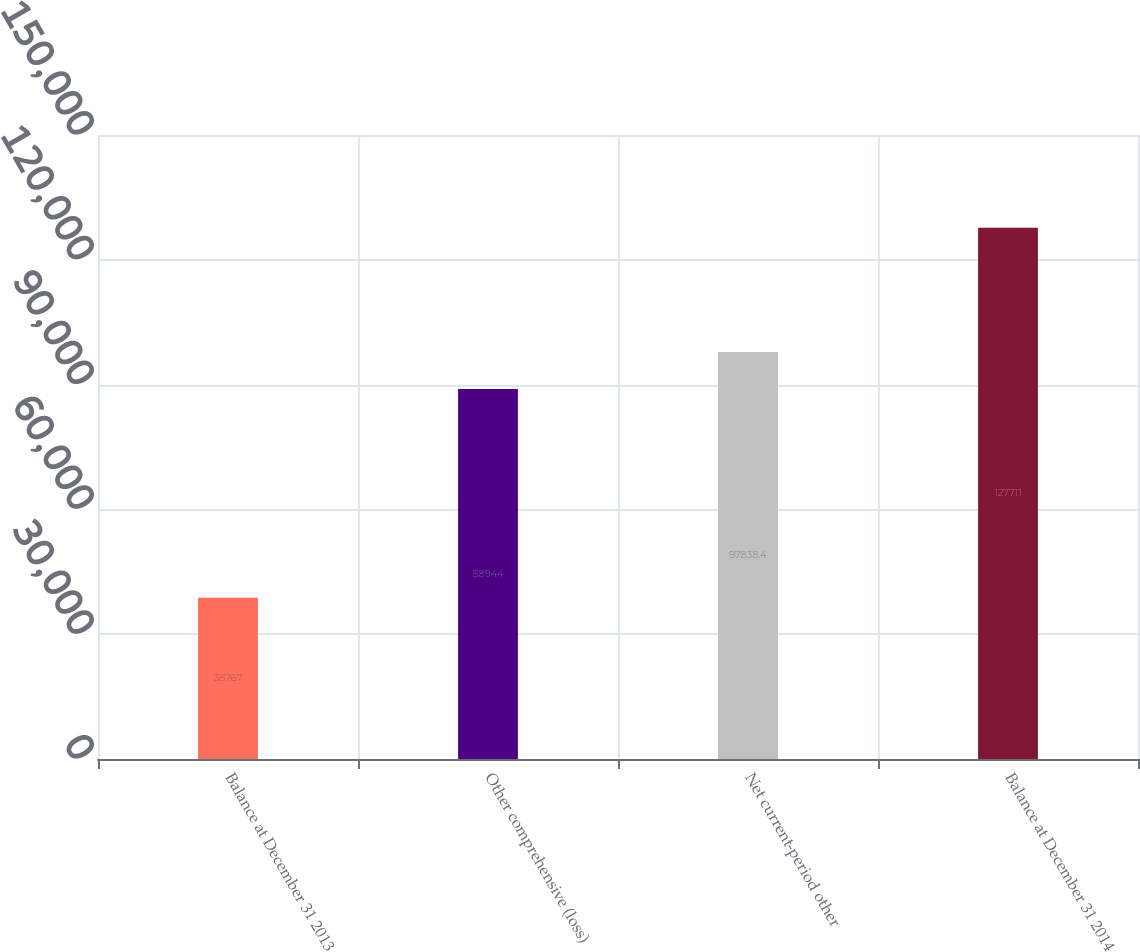<chart> <loc_0><loc_0><loc_500><loc_500><bar_chart><fcel>Balance at December 31 2013<fcel>Other comprehensive (loss)<fcel>Net current-period other<fcel>Balance at December 31 2014<nl><fcel>38767<fcel>88944<fcel>97838.4<fcel>127711<nl></chart> 